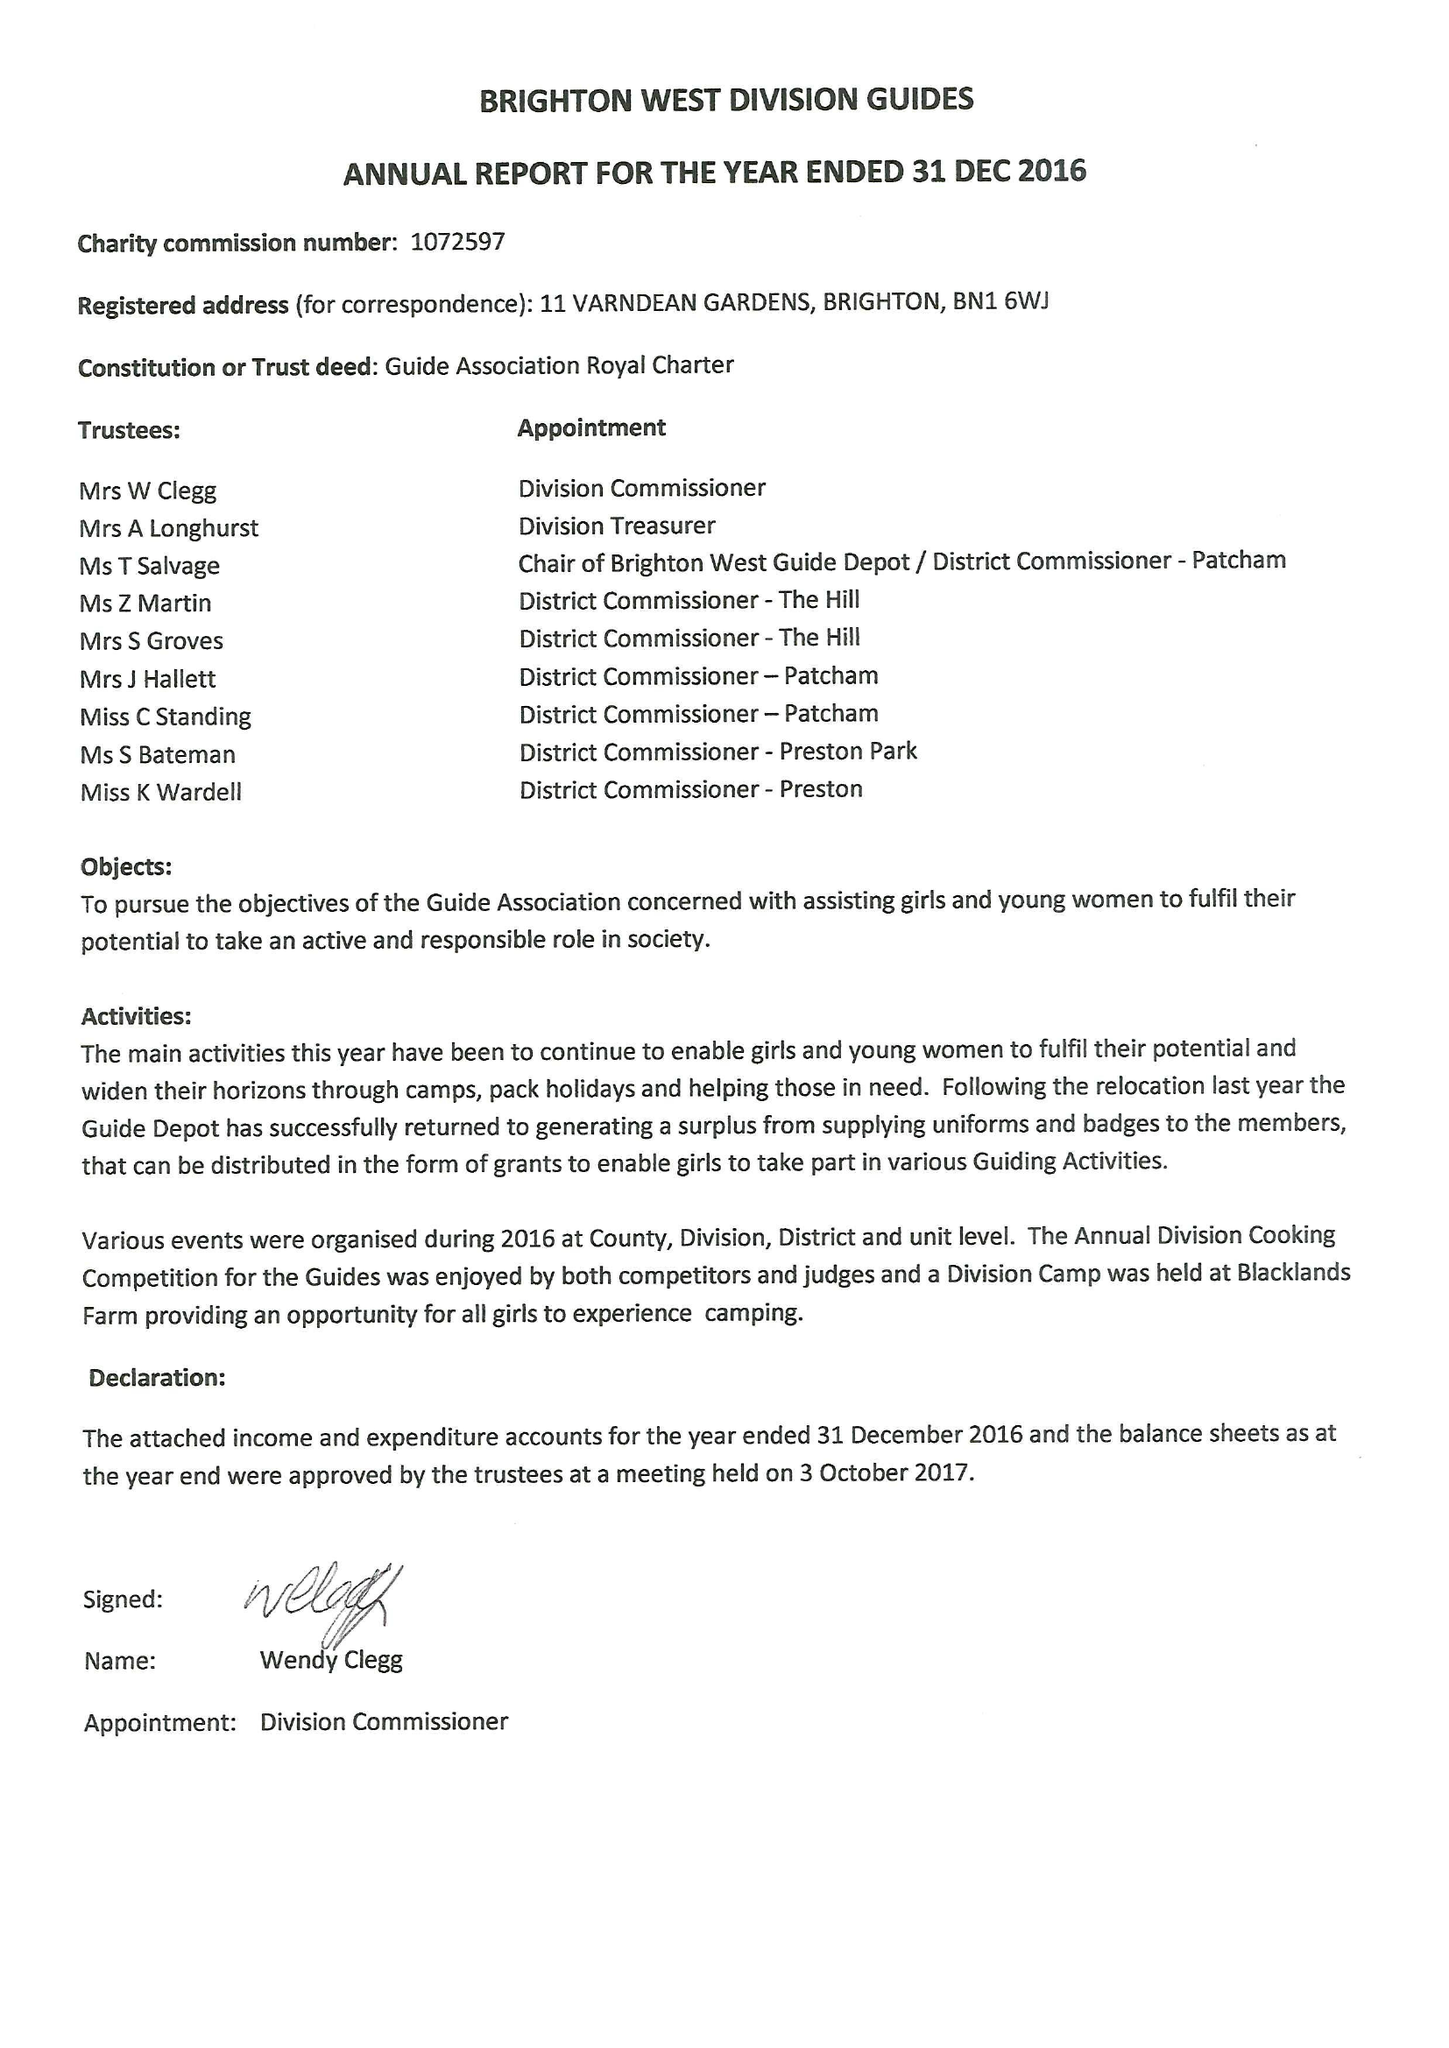What is the value for the charity_number?
Answer the question using a single word or phrase. 1072597 